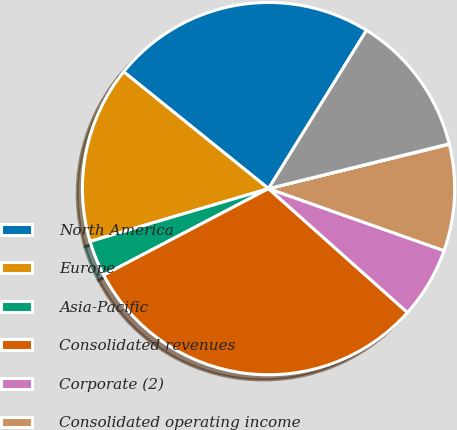<chart> <loc_0><loc_0><loc_500><loc_500><pie_chart><fcel>North America<fcel>Europe<fcel>Asia-Pacific<fcel>Consolidated revenues<fcel>Corporate (2)<fcel>Consolidated operating income<fcel>Corporate<fcel>Consolidated depreciation and<nl><fcel>23.02%<fcel>15.38%<fcel>3.11%<fcel>30.72%<fcel>6.18%<fcel>9.24%<fcel>0.04%<fcel>12.31%<nl></chart> 